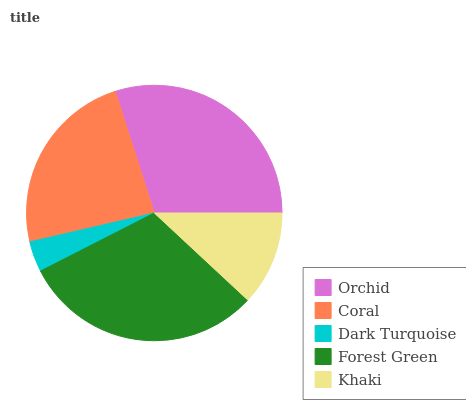Is Dark Turquoise the minimum?
Answer yes or no. Yes. Is Forest Green the maximum?
Answer yes or no. Yes. Is Coral the minimum?
Answer yes or no. No. Is Coral the maximum?
Answer yes or no. No. Is Orchid greater than Coral?
Answer yes or no. Yes. Is Coral less than Orchid?
Answer yes or no. Yes. Is Coral greater than Orchid?
Answer yes or no. No. Is Orchid less than Coral?
Answer yes or no. No. Is Coral the high median?
Answer yes or no. Yes. Is Coral the low median?
Answer yes or no. Yes. Is Orchid the high median?
Answer yes or no. No. Is Forest Green the low median?
Answer yes or no. No. 